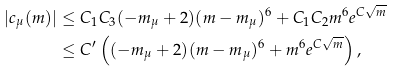<formula> <loc_0><loc_0><loc_500><loc_500>| c _ { \mu } ( m ) | & \leq C _ { 1 } C _ { 3 } ( - m _ { \mu } + 2 ) ( m - m _ { \mu } ) ^ { 6 } + C _ { 1 } C _ { 2 } m ^ { 6 } e ^ { C \sqrt { m } } \\ & \leq C ^ { \prime } \left ( ( - m _ { \mu } + 2 ) ( m - m _ { \mu } ) ^ { 6 } + m ^ { 6 } e ^ { C \sqrt { m } } \right ) ,</formula> 